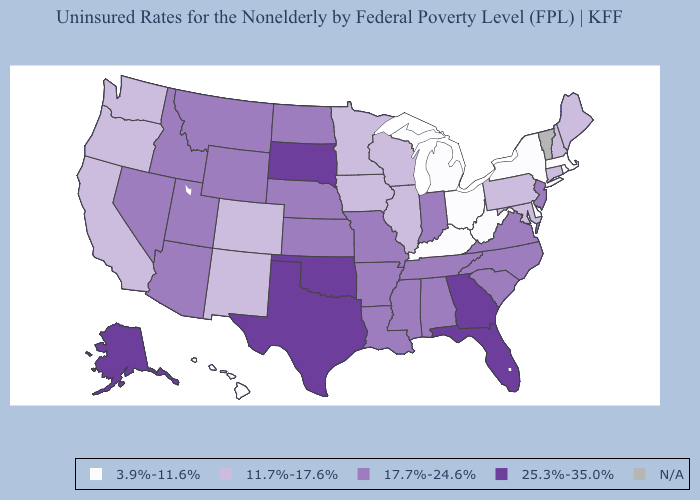Name the states that have a value in the range N/A?
Answer briefly. Vermont. Which states have the lowest value in the MidWest?
Be succinct. Michigan, Ohio. Does New Hampshire have the lowest value in the USA?
Concise answer only. No. Which states have the lowest value in the USA?
Keep it brief. Delaware, Hawaii, Kentucky, Massachusetts, Michigan, New York, Ohio, Rhode Island, West Virginia. Name the states that have a value in the range 3.9%-11.6%?
Answer briefly. Delaware, Hawaii, Kentucky, Massachusetts, Michigan, New York, Ohio, Rhode Island, West Virginia. Does Maine have the lowest value in the USA?
Be succinct. No. What is the value of Georgia?
Keep it brief. 25.3%-35.0%. Name the states that have a value in the range 17.7%-24.6%?
Be succinct. Alabama, Arizona, Arkansas, Idaho, Indiana, Kansas, Louisiana, Mississippi, Missouri, Montana, Nebraska, Nevada, New Jersey, North Carolina, North Dakota, South Carolina, Tennessee, Utah, Virginia, Wyoming. Which states have the highest value in the USA?
Write a very short answer. Alaska, Florida, Georgia, Oklahoma, South Dakota, Texas. Name the states that have a value in the range 11.7%-17.6%?
Be succinct. California, Colorado, Connecticut, Illinois, Iowa, Maine, Maryland, Minnesota, New Hampshire, New Mexico, Oregon, Pennsylvania, Washington, Wisconsin. Name the states that have a value in the range 3.9%-11.6%?
Short answer required. Delaware, Hawaii, Kentucky, Massachusetts, Michigan, New York, Ohio, Rhode Island, West Virginia. Which states have the lowest value in the USA?
Quick response, please. Delaware, Hawaii, Kentucky, Massachusetts, Michigan, New York, Ohio, Rhode Island, West Virginia. Name the states that have a value in the range 25.3%-35.0%?
Answer briefly. Alaska, Florida, Georgia, Oklahoma, South Dakota, Texas. 